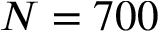<formula> <loc_0><loc_0><loc_500><loc_500>N = 7 0 0</formula> 